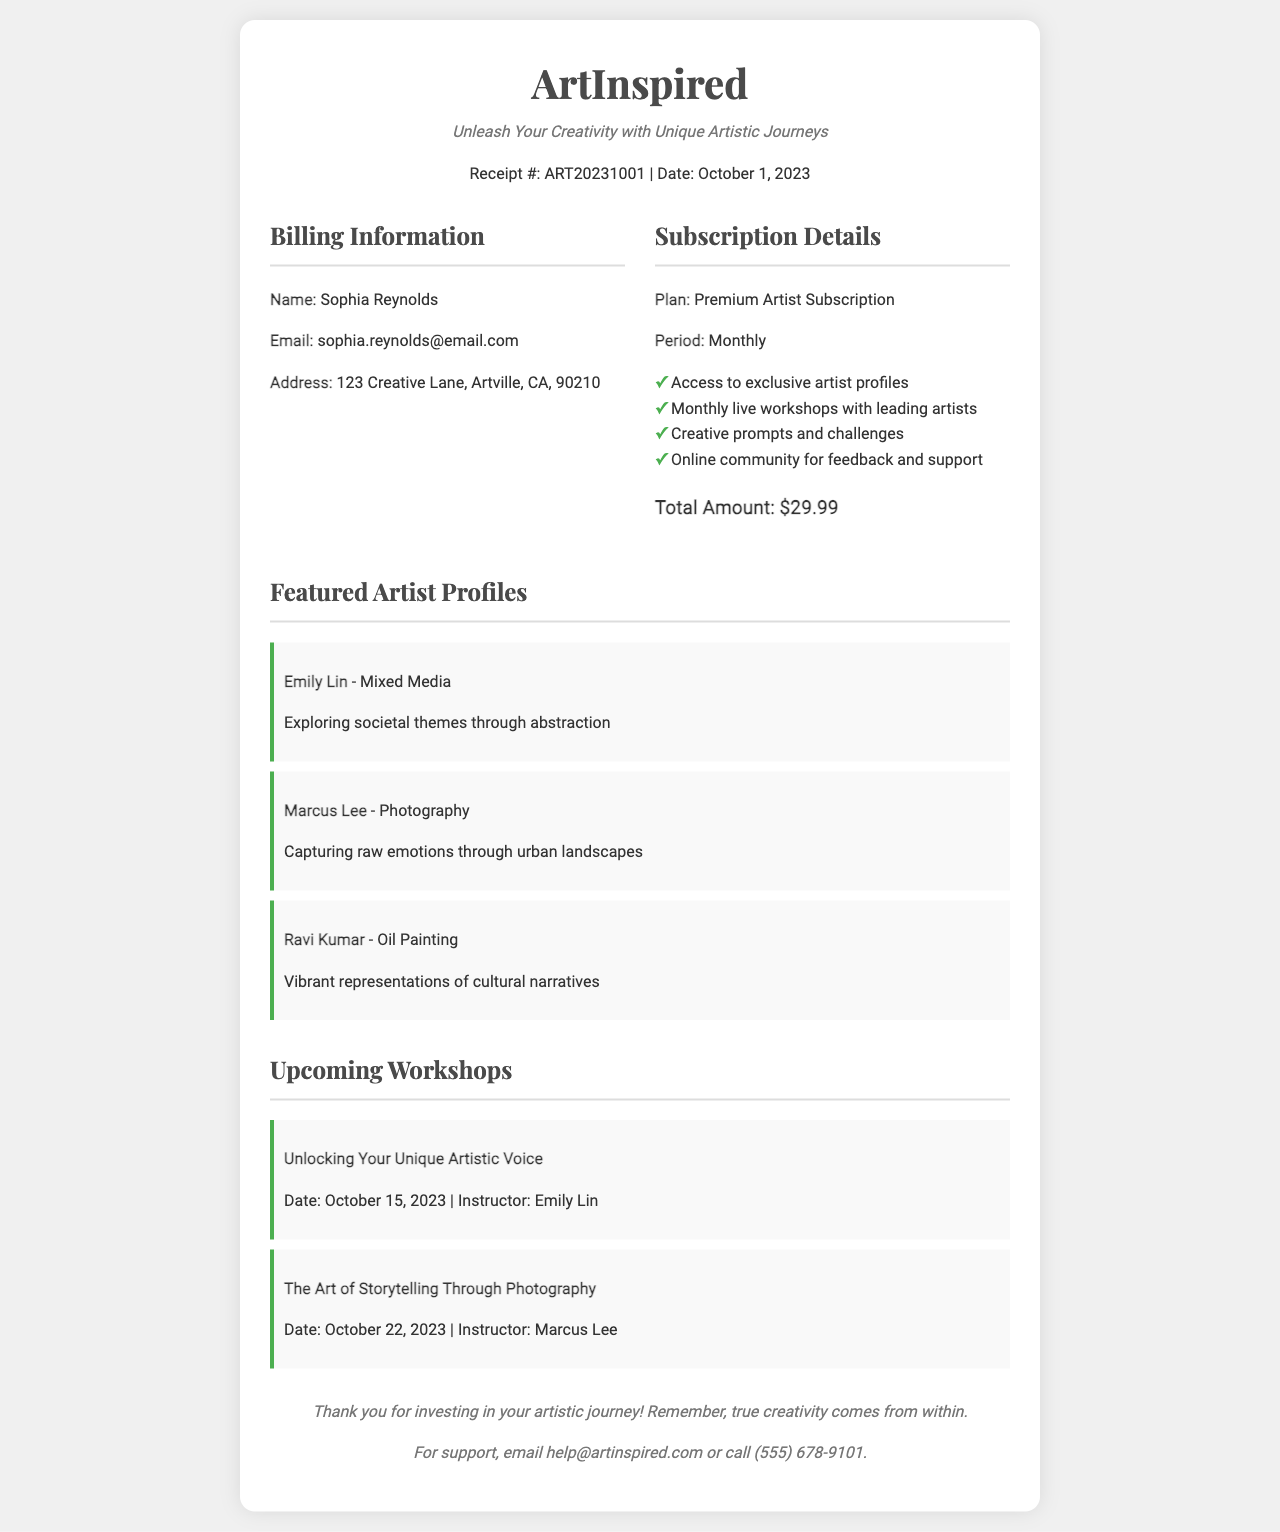What is the name of the subscriber? The subscriber's name is provided in the billing information section of the document.
Answer: Sophia Reynolds What is the email address of the subscriber? The email address is also listed in the billing information section.
Answer: sophia.reynolds@email.com What is the subscription plan type? The plan type is specified in the subscription details section of the document.
Answer: Premium Artist Subscription What is the total amount charged for the subscription? The total amount is noted in the subscription details section as the final cost.
Answer: $29.99 When is the first upcoming workshop scheduled? The date of the first upcoming workshop is given in the workshops section.
Answer: October 15, 2023 What is the name of the featured artist who teaches the first workshop? The instructor for the first workshop is mentioned in the workshops section.
Answer: Emily Lin How many features are included in the subscription? The number of features can be determined by counting the list items in the subscription details.
Answer: 4 What is the tagline for ArtInspired? The tagline is found under the header of the receipt.
Answer: Unleash Your Creativity with Unique Artistic Journeys What is the address listed for the subscriber? The subscriber's address is provided in the billing information section.
Answer: 123 Creative Lane, Artville, CA, 90210 